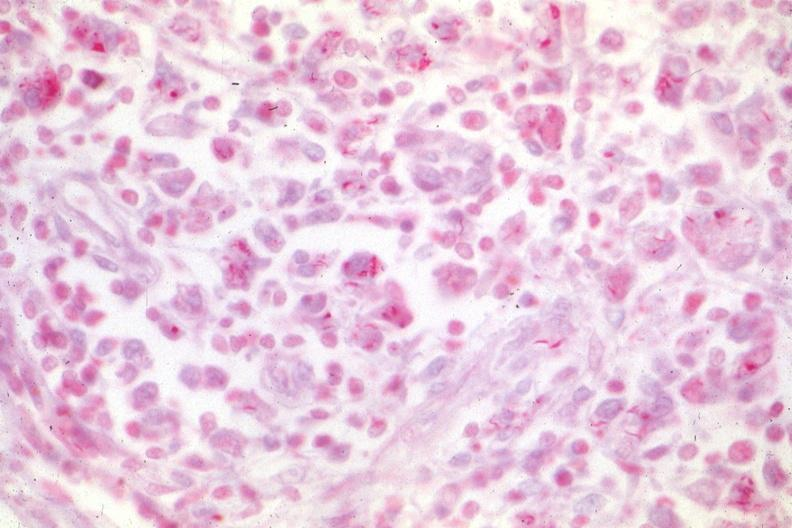s lymph node present?
Answer the question using a single word or phrase. Yes 